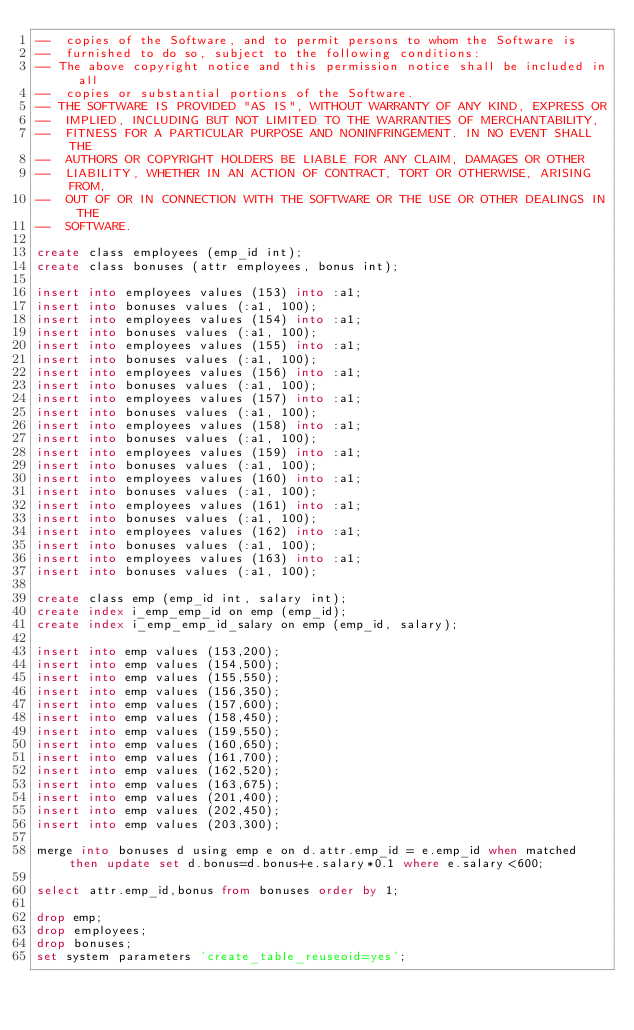<code> <loc_0><loc_0><loc_500><loc_500><_SQL_>--  copies of the Software, and to permit persons to whom the Software is
--  furnished to do so, subject to the following conditions:
-- The above copyright notice and this permission notice shall be included in all
--  copies or substantial portions of the Software.
-- THE SOFTWARE IS PROVIDED "AS IS", WITHOUT WARRANTY OF ANY KIND, EXPRESS OR
--  IMPLIED, INCLUDING BUT NOT LIMITED TO THE WARRANTIES OF MERCHANTABILITY,
--  FITNESS FOR A PARTICULAR PURPOSE AND NONINFRINGEMENT. IN NO EVENT SHALL THE
--  AUTHORS OR COPYRIGHT HOLDERS BE LIABLE FOR ANY CLAIM, DAMAGES OR OTHER
--  LIABILITY, WHETHER IN AN ACTION OF CONTRACT, TORT OR OTHERWISE, ARISING FROM,
--  OUT OF OR IN CONNECTION WITH THE SOFTWARE OR THE USE OR OTHER DEALINGS IN THE
--  SOFTWARE.

create class employees (emp_id int);
create class bonuses (attr employees, bonus int);

insert into employees values (153) into :a1;
insert into bonuses values (:a1, 100);
insert into employees values (154) into :a1;
insert into bonuses values (:a1, 100);
insert into employees values (155) into :a1;
insert into bonuses values (:a1, 100);
insert into employees values (156) into :a1;
insert into bonuses values (:a1, 100);
insert into employees values (157) into :a1;
insert into bonuses values (:a1, 100);
insert into employees values (158) into :a1;
insert into bonuses values (:a1, 100);
insert into employees values (159) into :a1;
insert into bonuses values (:a1, 100);
insert into employees values (160) into :a1;
insert into bonuses values (:a1, 100);
insert into employees values (161) into :a1;
insert into bonuses values (:a1, 100);
insert into employees values (162) into :a1;
insert into bonuses values (:a1, 100);
insert into employees values (163) into :a1;
insert into bonuses values (:a1, 100);

create class emp (emp_id int, salary int);
create index i_emp_emp_id on emp (emp_id);
create index i_emp_emp_id_salary on emp (emp_id, salary);

insert into emp values (153,200);
insert into emp values (154,500);
insert into emp values (155,550);
insert into emp values (156,350);
insert into emp values (157,600);
insert into emp values (158,450);
insert into emp values (159,550);
insert into emp values (160,650);
insert into emp values (161,700);
insert into emp values (162,520);
insert into emp values (163,675);
insert into emp values (201,400);
insert into emp values (202,450);
insert into emp values (203,300);

merge into bonuses d using emp e on d.attr.emp_id = e.emp_id when matched then update set d.bonus=d.bonus+e.salary*0.1 where e.salary<600;

select attr.emp_id,bonus from bonuses order by 1;

drop emp;
drop employees;
drop bonuses;
set system parameters 'create_table_reuseoid=yes';
</code> 